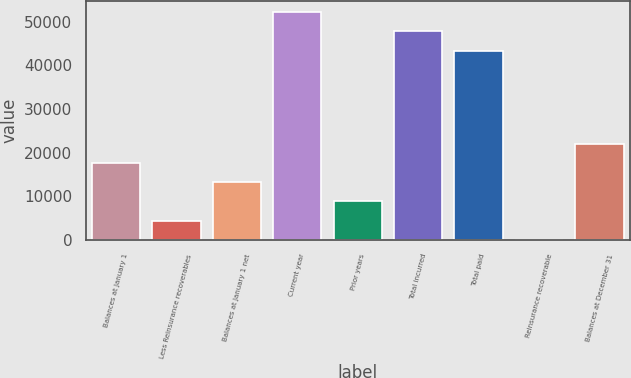Convert chart. <chart><loc_0><loc_0><loc_500><loc_500><bar_chart><fcel>Balances at January 1<fcel>Less Reinsurance recoverables<fcel>Balances at January 1 net<fcel>Current year<fcel>Prior years<fcel>Total incurred<fcel>Total paid<fcel>Reinsurance recoverable<fcel>Balances at December 31<nl><fcel>17642.4<fcel>4463.1<fcel>13249.3<fcel>52193.2<fcel>8856.2<fcel>47800.1<fcel>43407<fcel>70<fcel>22035.5<nl></chart> 